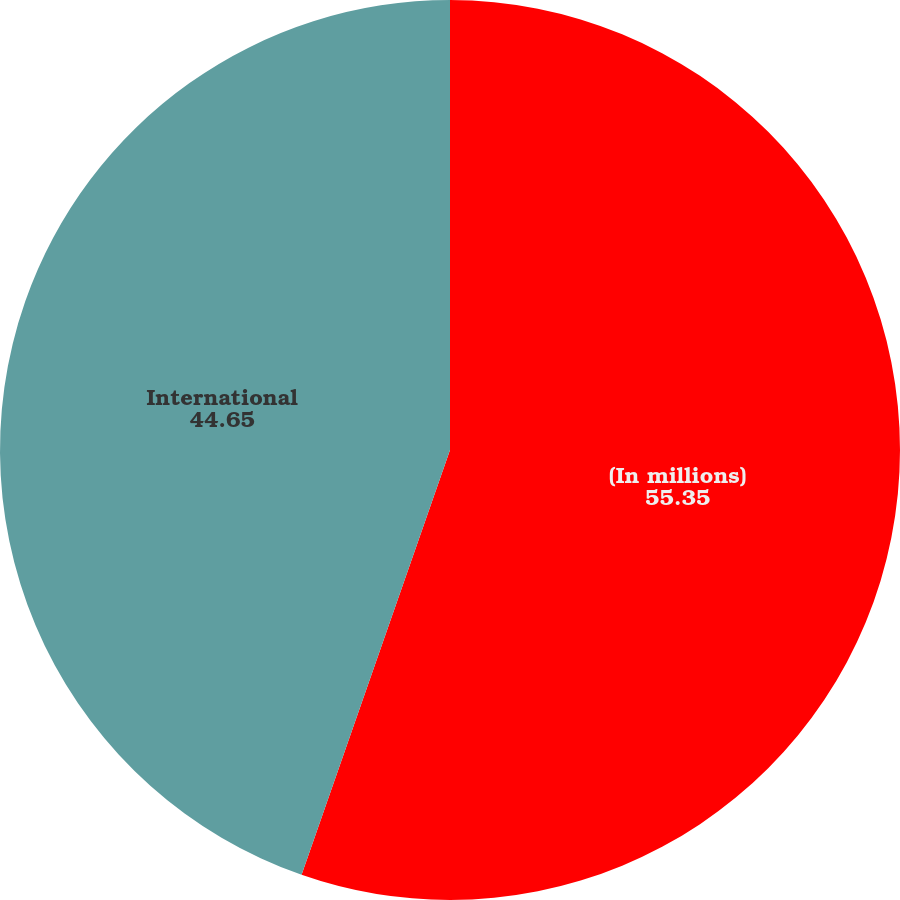Convert chart to OTSL. <chart><loc_0><loc_0><loc_500><loc_500><pie_chart><fcel>(In millions)<fcel>International<nl><fcel>55.35%<fcel>44.65%<nl></chart> 